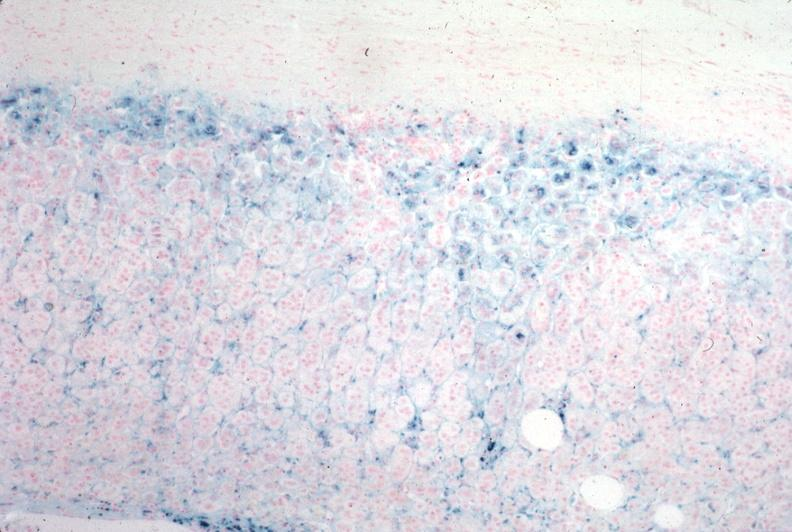where is this part in the figure?
Answer the question using a single word or phrase. Endocrine system 